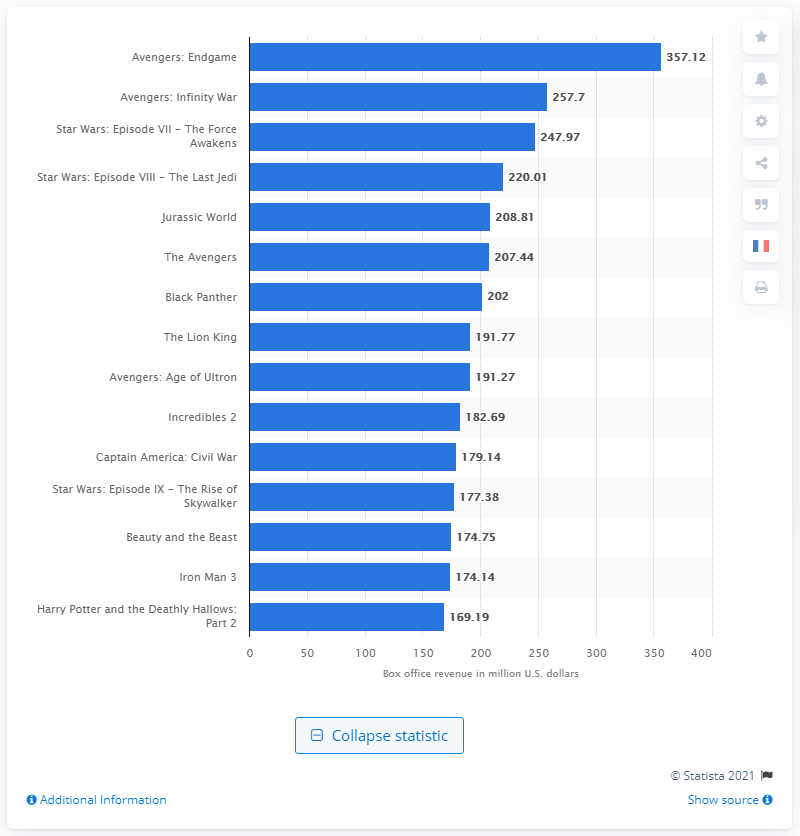List a handful of essential elements in this visual. Black Panther, the movie that debuted in North America's top fifteen biggest opening weekend, has achieved a significant feat in the entertainment industry. Avengers: Endgame grossed $357.12 million on its first weekend in theaters. 